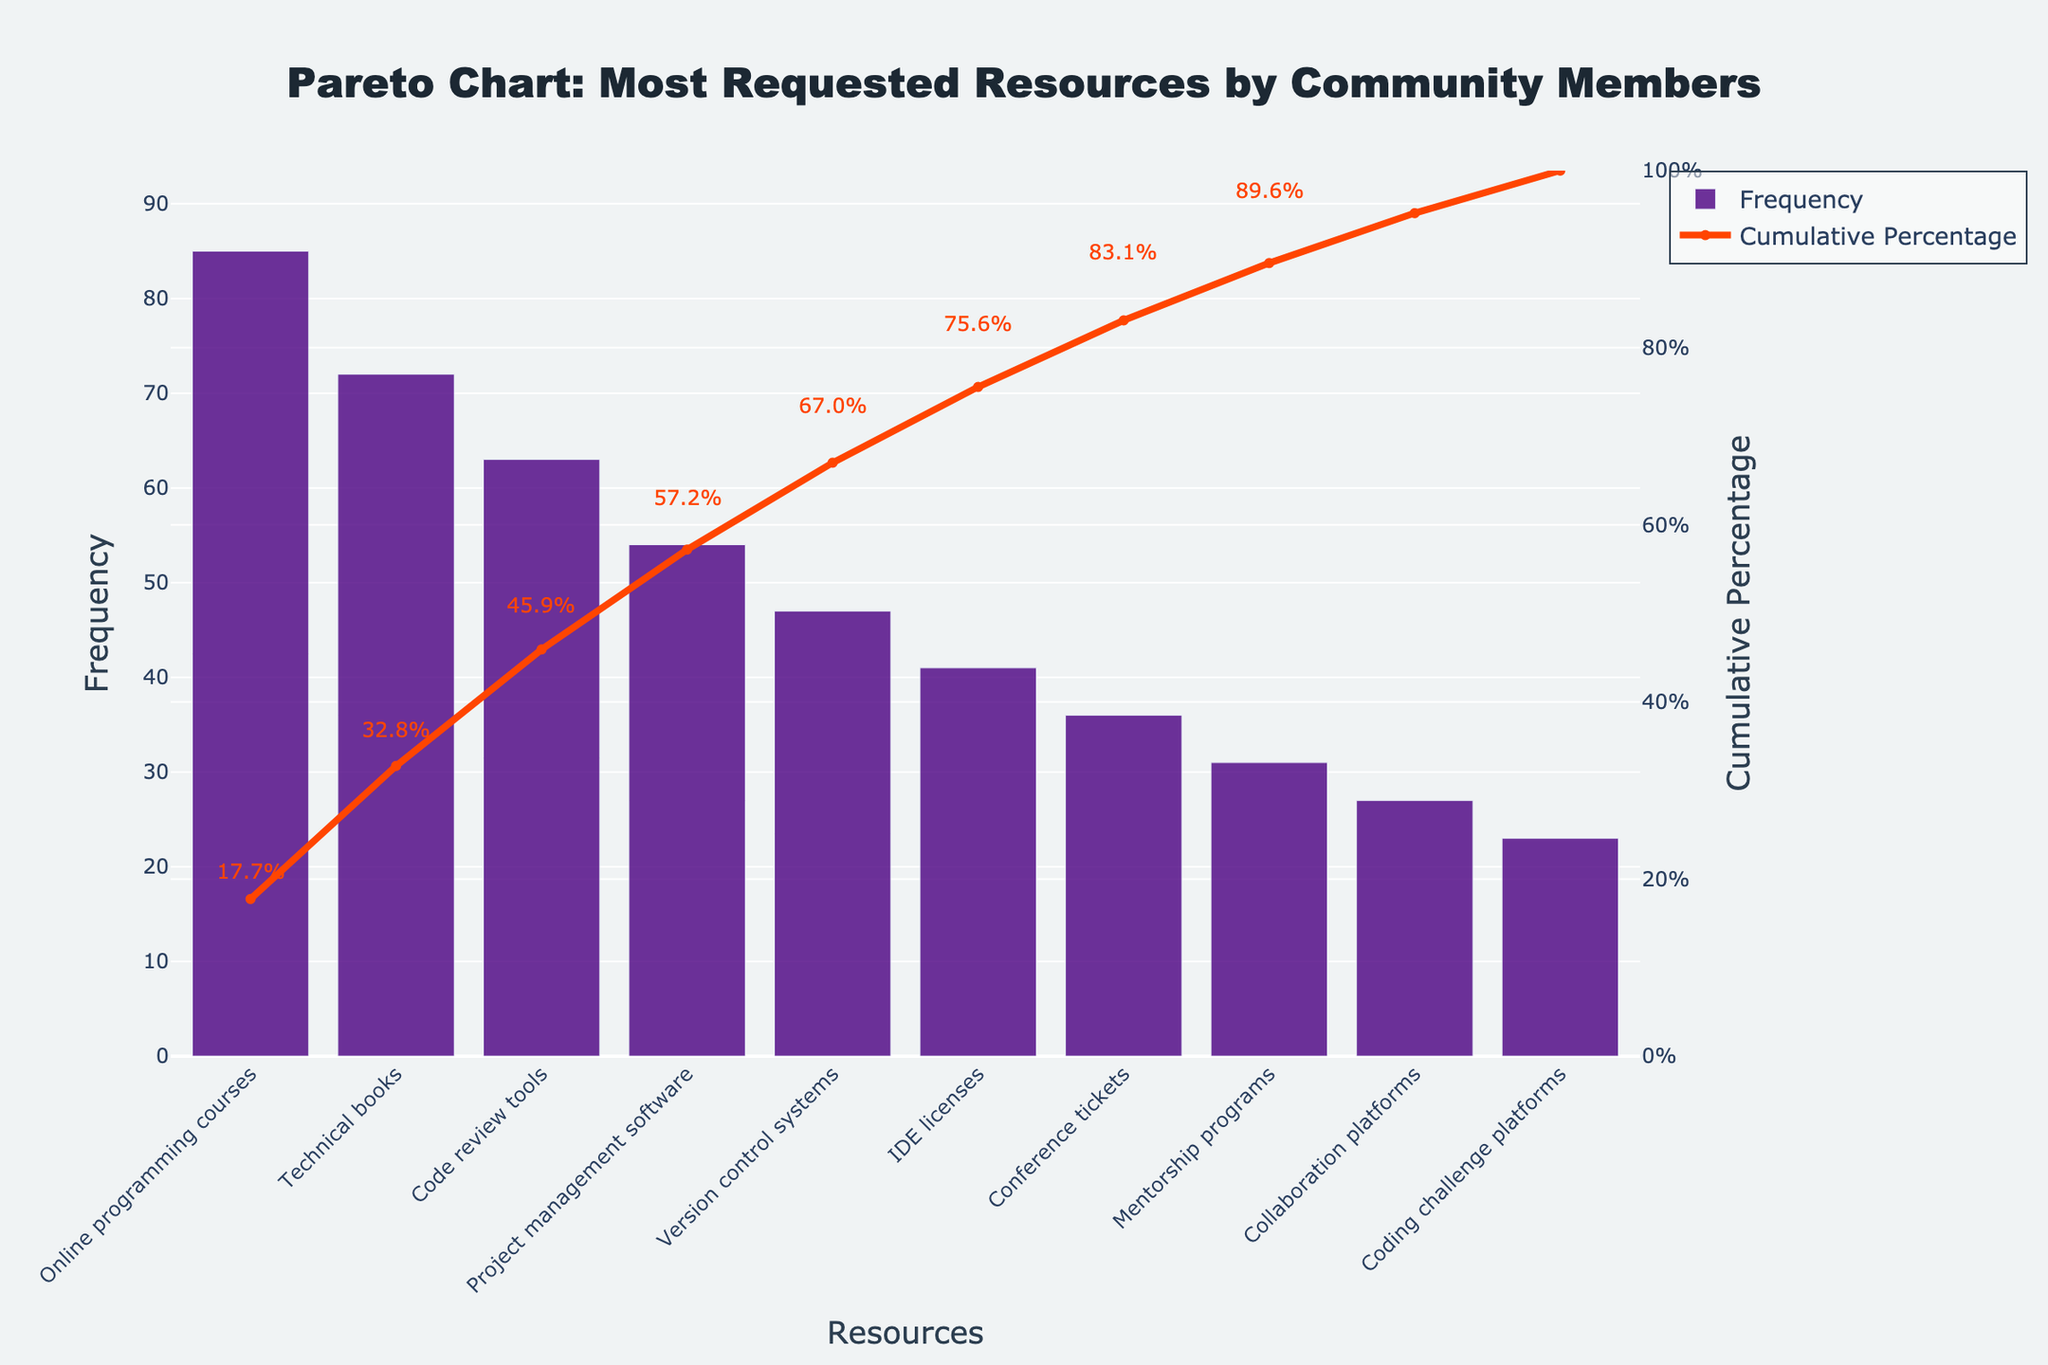What is the title of the chart? The title is written at the top of the chart and provides a summary of the chart's information.
Answer: Pareto Chart: Most Requested Resources by Community Members How many resources are listed in the chart? By counting the bars on the x-axis, you can determine the number of resources listed.
Answer: 10 Which resource has the highest frequency of requests? The resource with the tallest bar on the chart represents the highest frequency.
Answer: Online programming courses What is the cumulative percentage of the top three most requested resources? The cumulative percentage of the top three resources is calculated by adding their percentages shown on the secondary y-axis (right side).
Answer: 60.1% How does the frequency of "IDE licenses" compare to "Mentorship programs"? Look at the height of the bars corresponding to "IDE licenses" and "Mentorship programs" to compare.
Answer: IDE licenses have a higher frequency than Mentorship programs What percentage of requests do "Project management software" and "Version control systems" together account for? Add the individual frequencies of both resources and calculate their percentage based on the total requests.
Answer: Project management software and Version control systems together account for about 14.6% of the requests At what cumulative percentage does the "Cumulative Percentage" line cross after six resources? Look at where the line intersects after the sixth resource.
Answer: Approximately 67.3% Which three resources together make up just over half of the total requests? Identify the first set of resources where their cumulative percentage is slightly over 50%.
Answer: Online programming courses, Technical books, and Code review tools What can you infer about the least requested resources in the chart? Look at the shortest bars and their cumulative percentages to infer their demand.
Answer: Collaboration platforms and Coding challenge platforms are the least requested resources with the lowest frequencies What is the exact cumulative percentage associated with "Conference tickets"? Refer to the annotation next to "Conference tickets" for its cumulative percentage.
Answer: 73.4% 